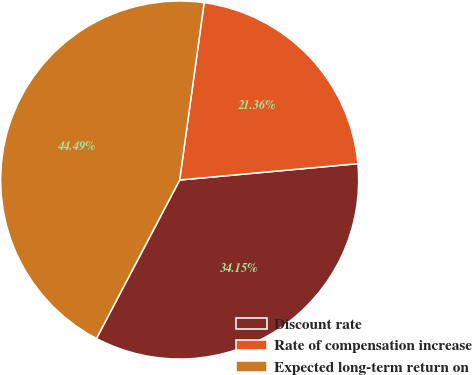Convert chart. <chart><loc_0><loc_0><loc_500><loc_500><pie_chart><fcel>Discount rate<fcel>Rate of compensation increase<fcel>Expected long-term return on<nl><fcel>34.15%<fcel>21.36%<fcel>44.49%<nl></chart> 